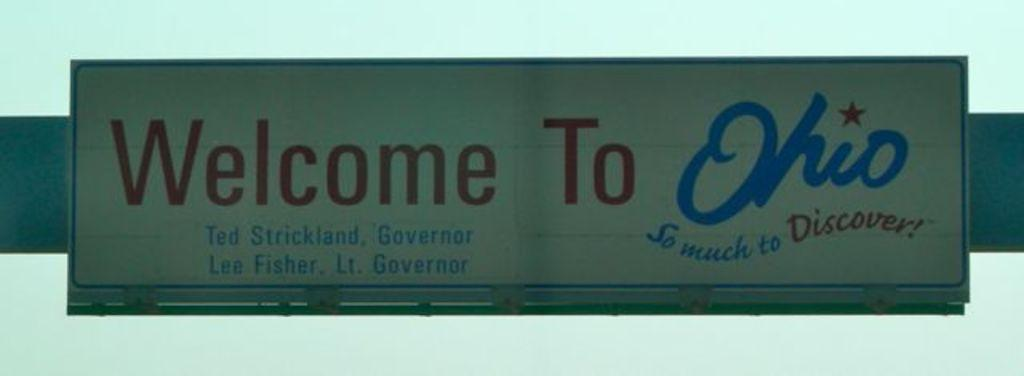<image>
Share a concise interpretation of the image provided. A road sign that reads Welcome to Ohio is displayed with red and blue letters on a white background. 